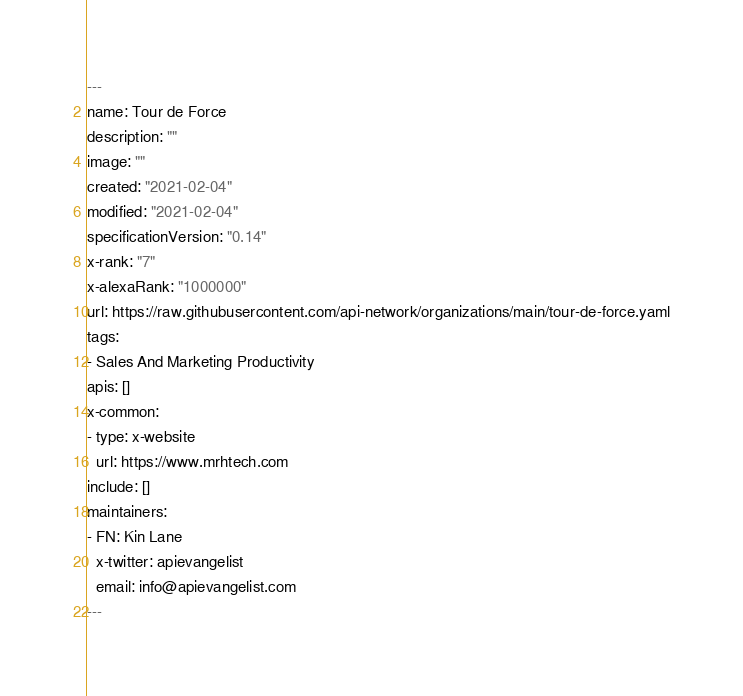Convert code to text. <code><loc_0><loc_0><loc_500><loc_500><_YAML_>---
name: Tour de Force
description: ""
image: ""
created: "2021-02-04"
modified: "2021-02-04"
specificationVersion: "0.14"
x-rank: "7"
x-alexaRank: "1000000"
url: https://raw.githubusercontent.com/api-network/organizations/main/tour-de-force.yaml
tags:
- Sales And Marketing Productivity
apis: []
x-common:
- type: x-website
  url: https://www.mrhtech.com
include: []
maintainers:
- FN: Kin Lane
  x-twitter: apievangelist
  email: info@apievangelist.com
---</code> 